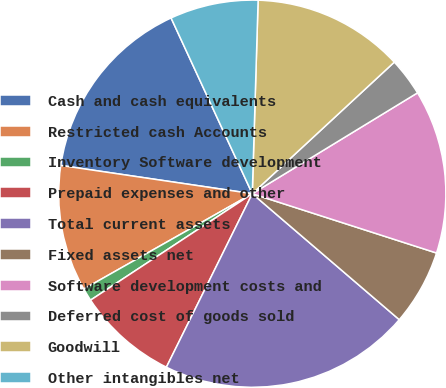Convert chart to OTSL. <chart><loc_0><loc_0><loc_500><loc_500><pie_chart><fcel>Cash and cash equivalents<fcel>Restricted cash Accounts<fcel>Inventory Software development<fcel>Prepaid expenses and other<fcel>Total current assets<fcel>Fixed assets net<fcel>Software development costs and<fcel>Deferred cost of goods sold<fcel>Goodwill<fcel>Other intangibles net<nl><fcel>15.78%<fcel>10.53%<fcel>1.07%<fcel>8.42%<fcel>21.04%<fcel>6.32%<fcel>13.68%<fcel>3.17%<fcel>12.63%<fcel>7.37%<nl></chart> 